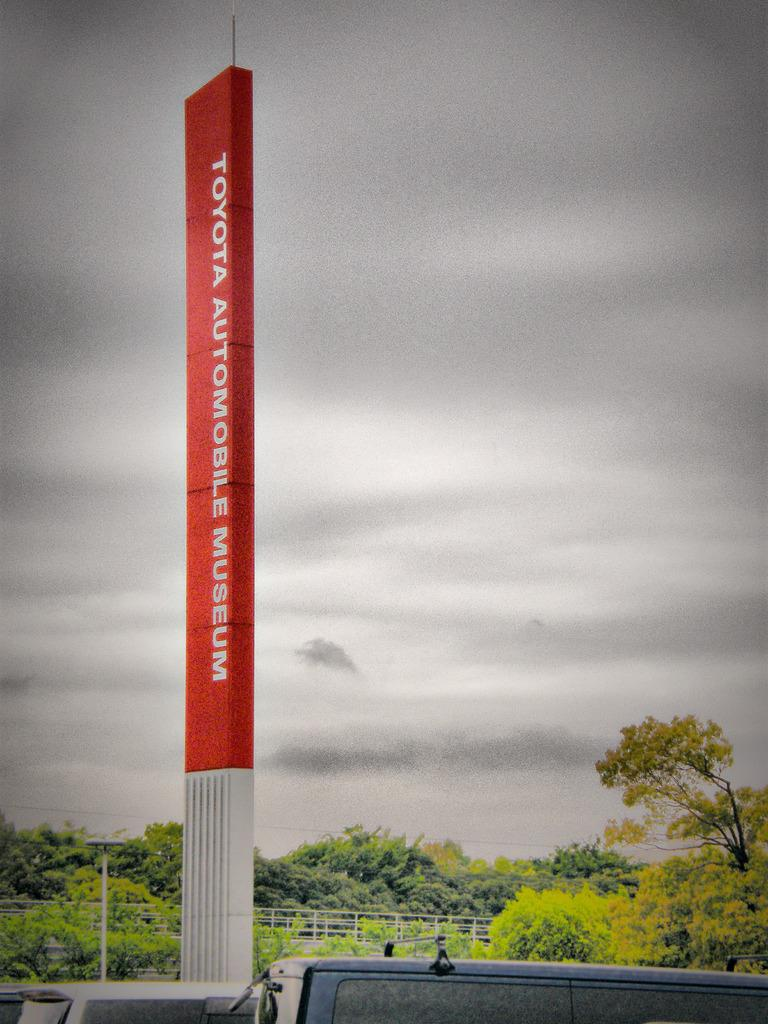Provide a one-sentence caption for the provided image. A large vertical sign in red reads "Toyota Automotive Museum.". 